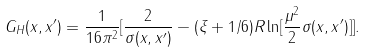<formula> <loc_0><loc_0><loc_500><loc_500>G _ { H } ( x , x ^ { \prime } ) = \frac { 1 } { 1 6 \pi ^ { 2 } } [ \frac { 2 } { \sigma ( x , x ^ { \prime } ) } - ( \xi + 1 / 6 ) R \ln [ \frac { \mu ^ { 2 } } 2 \sigma ( x , x ^ { \prime } ) ] ] .</formula> 